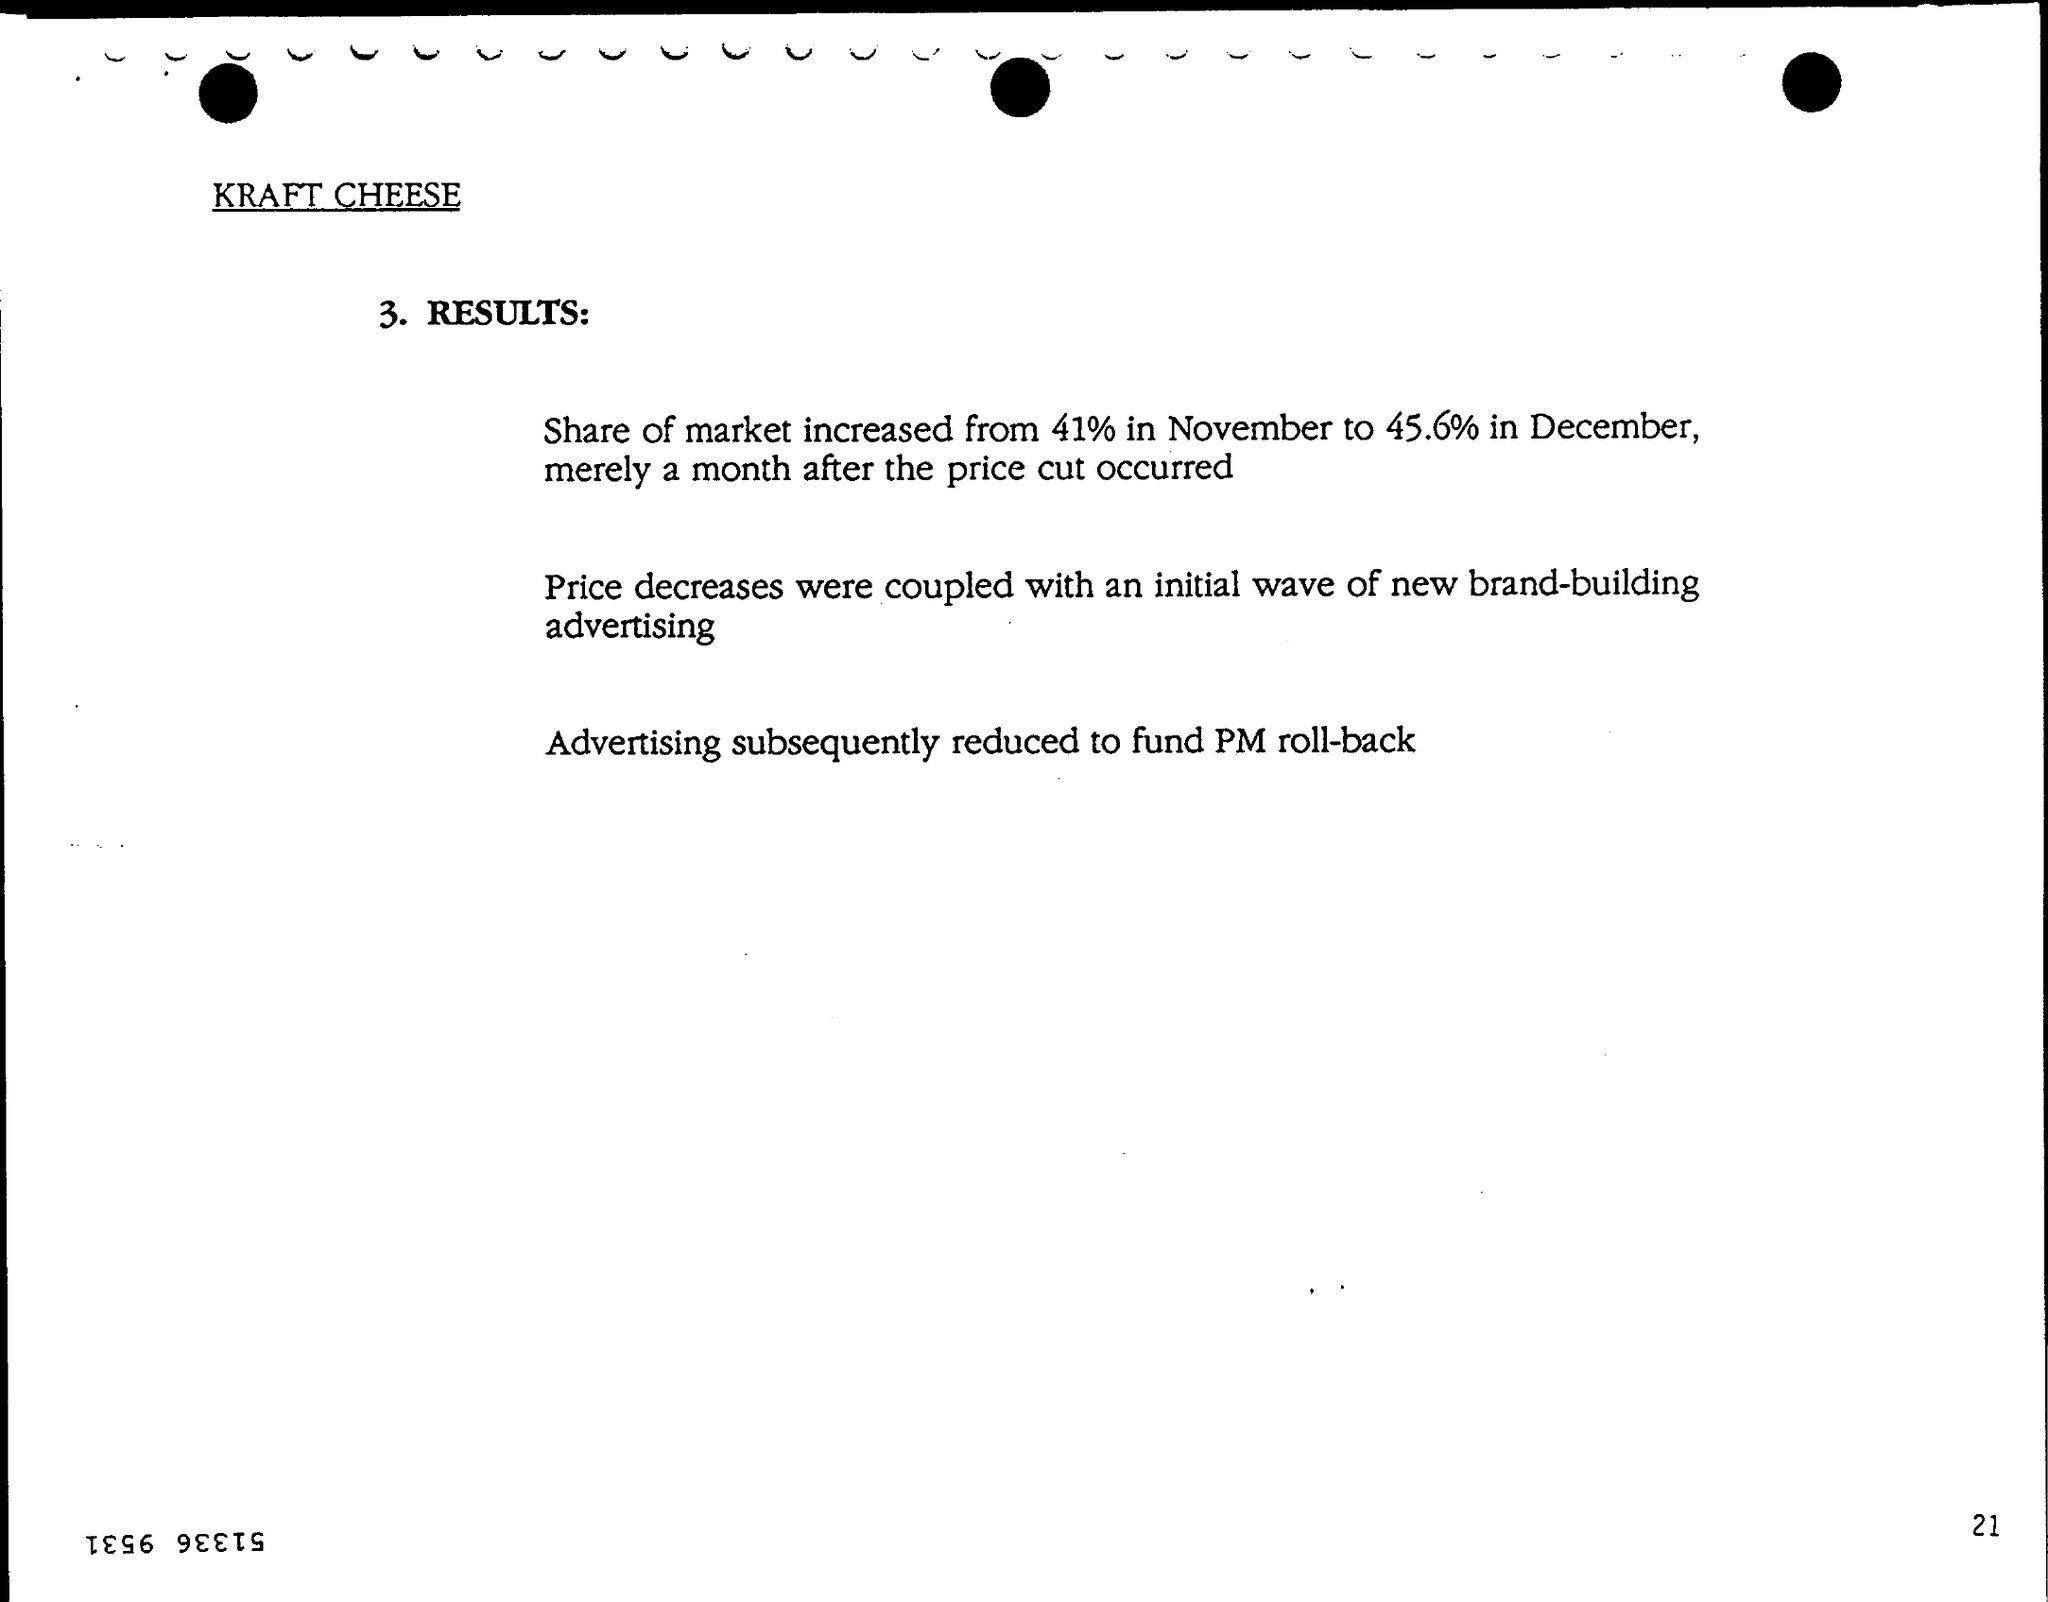Draw attention to some important aspects in this diagram. The page number is 21. The first title in the document is "Kraft Cheese..". 